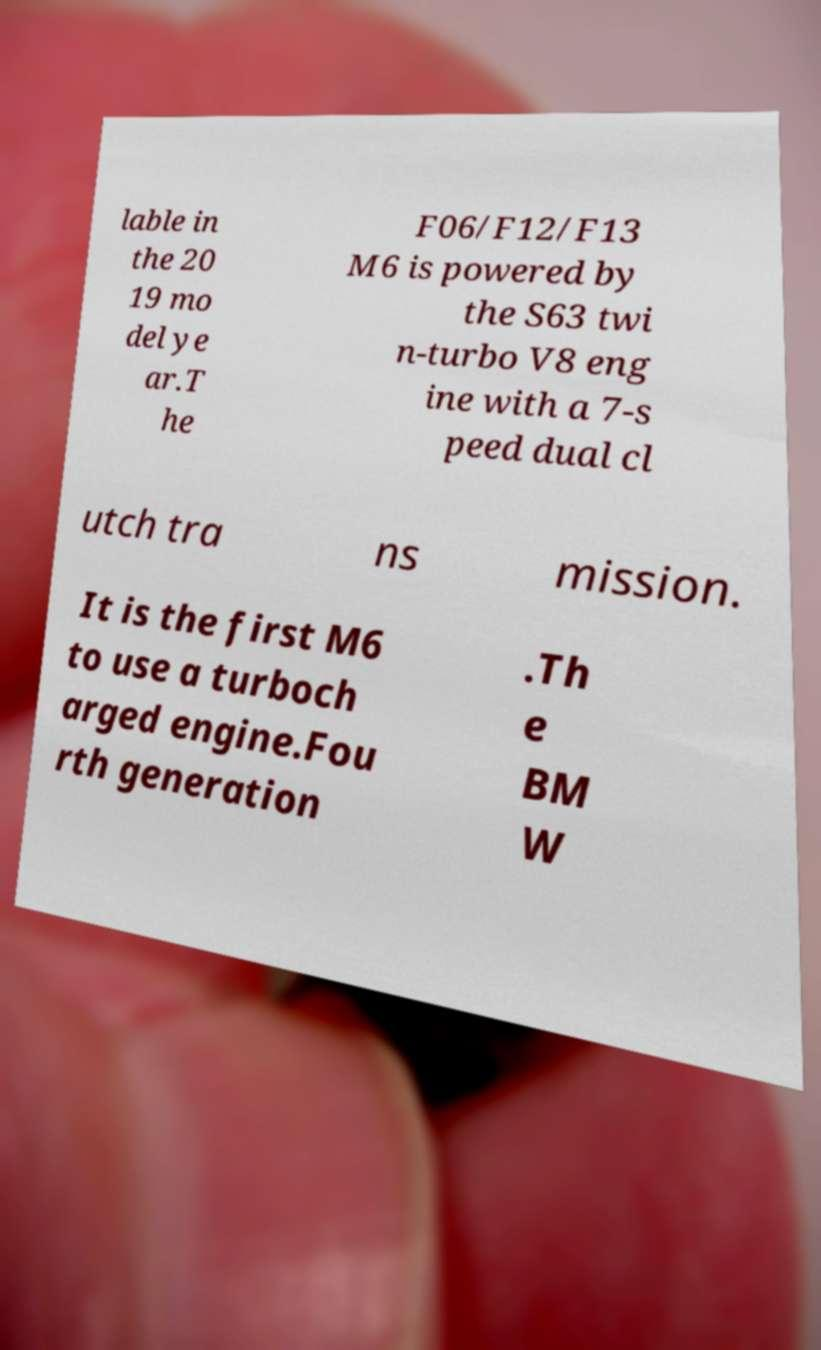Could you assist in decoding the text presented in this image and type it out clearly? lable in the 20 19 mo del ye ar.T he F06/F12/F13 M6 is powered by the S63 twi n-turbo V8 eng ine with a 7-s peed dual cl utch tra ns mission. It is the first M6 to use a turboch arged engine.Fou rth generation .Th e BM W 